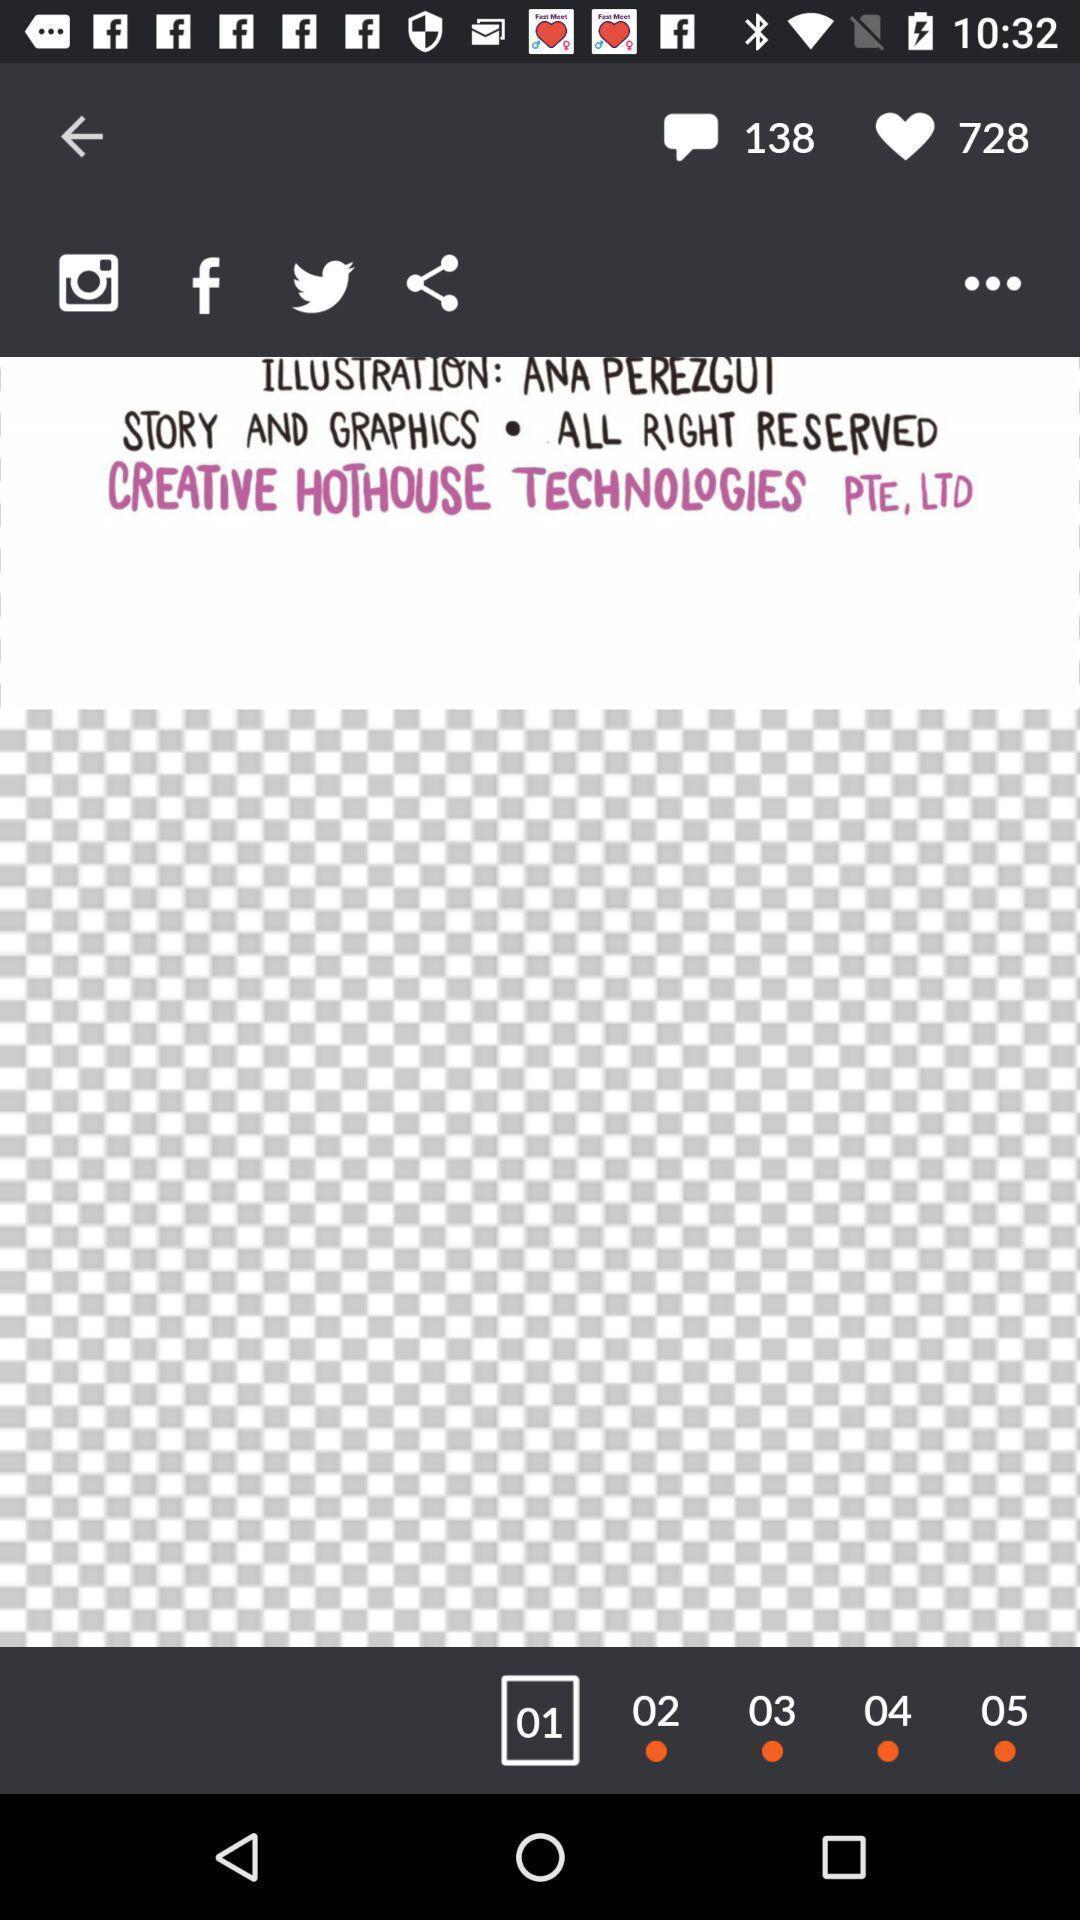Describe the visual elements of this screenshot. Page displaying various social applications. 